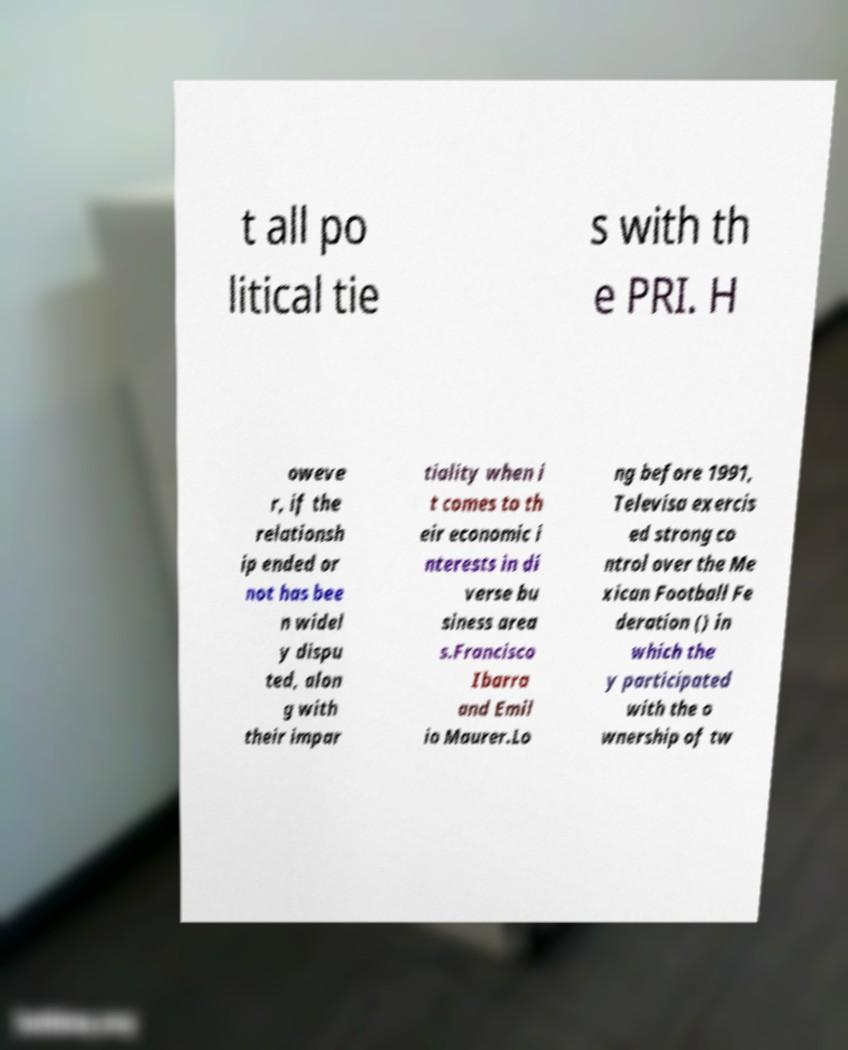Can you read and provide the text displayed in the image?This photo seems to have some interesting text. Can you extract and type it out for me? t all po litical tie s with th e PRI. H oweve r, if the relationsh ip ended or not has bee n widel y dispu ted, alon g with their impar tiality when i t comes to th eir economic i nterests in di verse bu siness area s.Francisco Ibarra and Emil io Maurer.Lo ng before 1991, Televisa exercis ed strong co ntrol over the Me xican Football Fe deration () in which the y participated with the o wnership of tw 